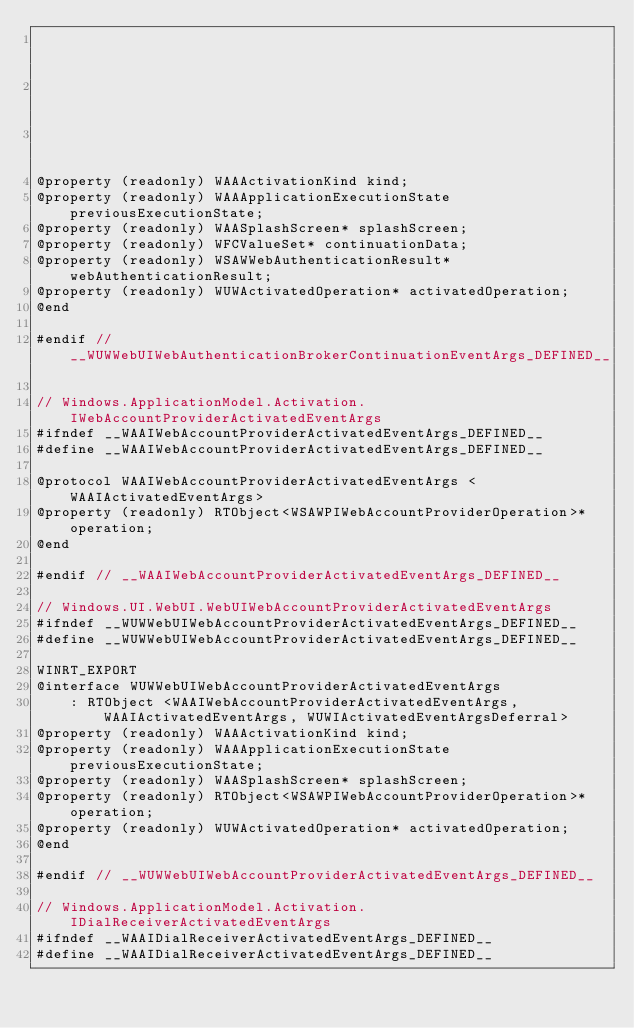Convert code to text. <code><loc_0><loc_0><loc_500><loc_500><_C_>                                                                            WAAIContinuationActivatedEventArgs,
                                                                            WAAIActivatedEventArgs,
                                                                            WUWIActivatedEventArgsDeferral>
@property (readonly) WAAActivationKind kind;
@property (readonly) WAAApplicationExecutionState previousExecutionState;
@property (readonly) WAASplashScreen* splashScreen;
@property (readonly) WFCValueSet* continuationData;
@property (readonly) WSAWWebAuthenticationResult* webAuthenticationResult;
@property (readonly) WUWActivatedOperation* activatedOperation;
@end

#endif // __WUWWebUIWebAuthenticationBrokerContinuationEventArgs_DEFINED__

// Windows.ApplicationModel.Activation.IWebAccountProviderActivatedEventArgs
#ifndef __WAAIWebAccountProviderActivatedEventArgs_DEFINED__
#define __WAAIWebAccountProviderActivatedEventArgs_DEFINED__

@protocol WAAIWebAccountProviderActivatedEventArgs <WAAIActivatedEventArgs>
@property (readonly) RTObject<WSAWPIWebAccountProviderOperation>* operation;
@end

#endif // __WAAIWebAccountProviderActivatedEventArgs_DEFINED__

// Windows.UI.WebUI.WebUIWebAccountProviderActivatedEventArgs
#ifndef __WUWWebUIWebAccountProviderActivatedEventArgs_DEFINED__
#define __WUWWebUIWebAccountProviderActivatedEventArgs_DEFINED__

WINRT_EXPORT
@interface WUWWebUIWebAccountProviderActivatedEventArgs
    : RTObject <WAAIWebAccountProviderActivatedEventArgs, WAAIActivatedEventArgs, WUWIActivatedEventArgsDeferral>
@property (readonly) WAAActivationKind kind;
@property (readonly) WAAApplicationExecutionState previousExecutionState;
@property (readonly) WAASplashScreen* splashScreen;
@property (readonly) RTObject<WSAWPIWebAccountProviderOperation>* operation;
@property (readonly) WUWActivatedOperation* activatedOperation;
@end

#endif // __WUWWebUIWebAccountProviderActivatedEventArgs_DEFINED__

// Windows.ApplicationModel.Activation.IDialReceiverActivatedEventArgs
#ifndef __WAAIDialReceiverActivatedEventArgs_DEFINED__
#define __WAAIDialReceiverActivatedEventArgs_DEFINED__
</code> 